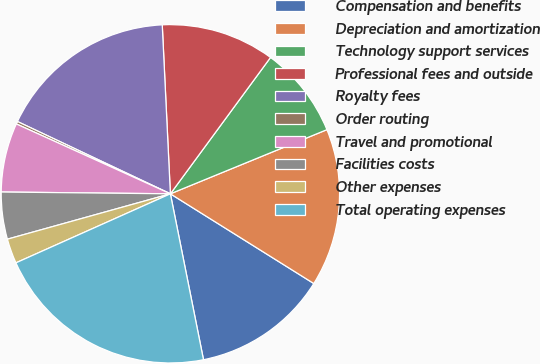Convert chart to OTSL. <chart><loc_0><loc_0><loc_500><loc_500><pie_chart><fcel>Compensation and benefits<fcel>Depreciation and amortization<fcel>Technology support services<fcel>Professional fees and outside<fcel>Royalty fees<fcel>Order routing<fcel>Travel and promotional<fcel>Facilities costs<fcel>Other expenses<fcel>Total operating expenses<nl><fcel>12.97%<fcel>15.09%<fcel>8.73%<fcel>10.85%<fcel>17.21%<fcel>0.25%<fcel>6.61%<fcel>4.49%<fcel>2.37%<fcel>21.45%<nl></chart> 